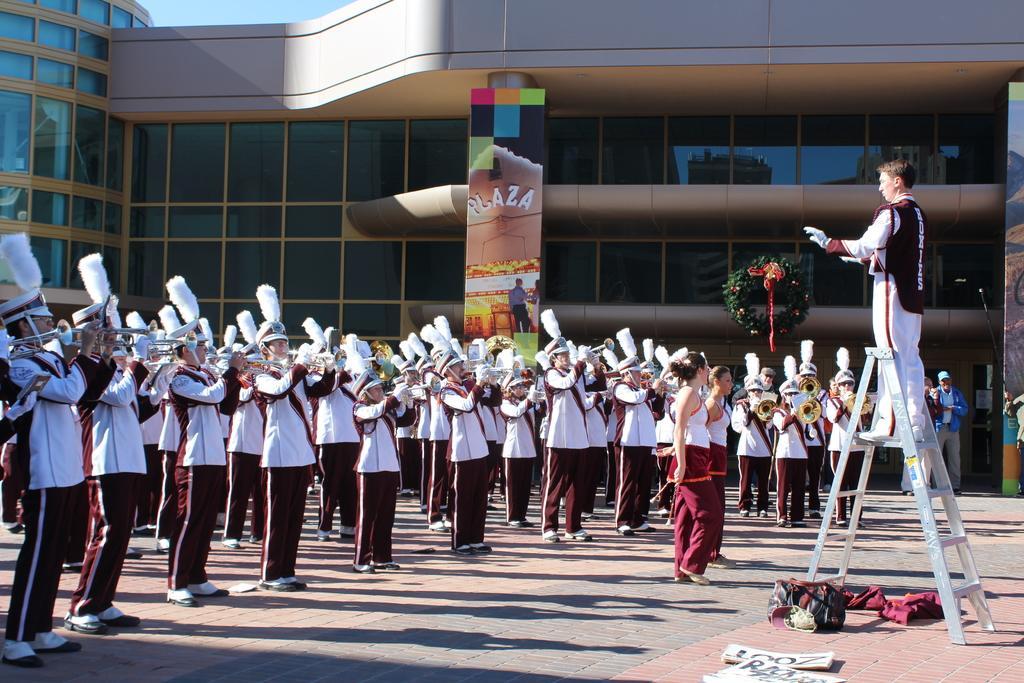In one or two sentences, can you explain what this image depicts? In the picture we can see many people are standing on the path with same uniform and holding musical instruments and playing it and in front of them, we can see two women are standing and in front of them, we can see a man standing on a ladder and in the background, we can see a building with black colored glasses to it and a hoarding with a name plaza on it and on the top of the building we can see a part of the sky. 